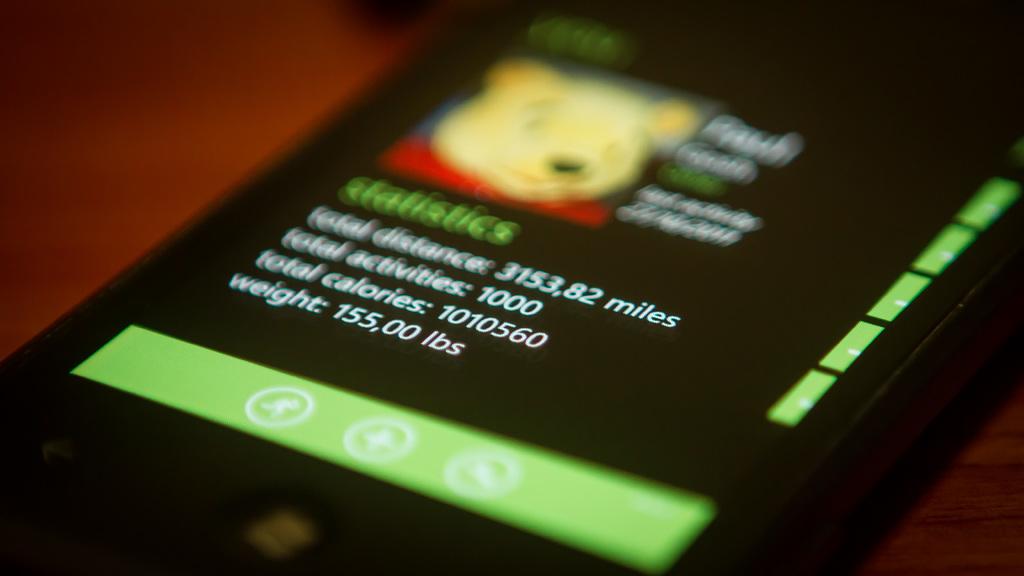How much does he weigh?
Your answer should be very brief. 155,00 lbs. How many total activities have been logged?
Provide a succinct answer. 1000. 